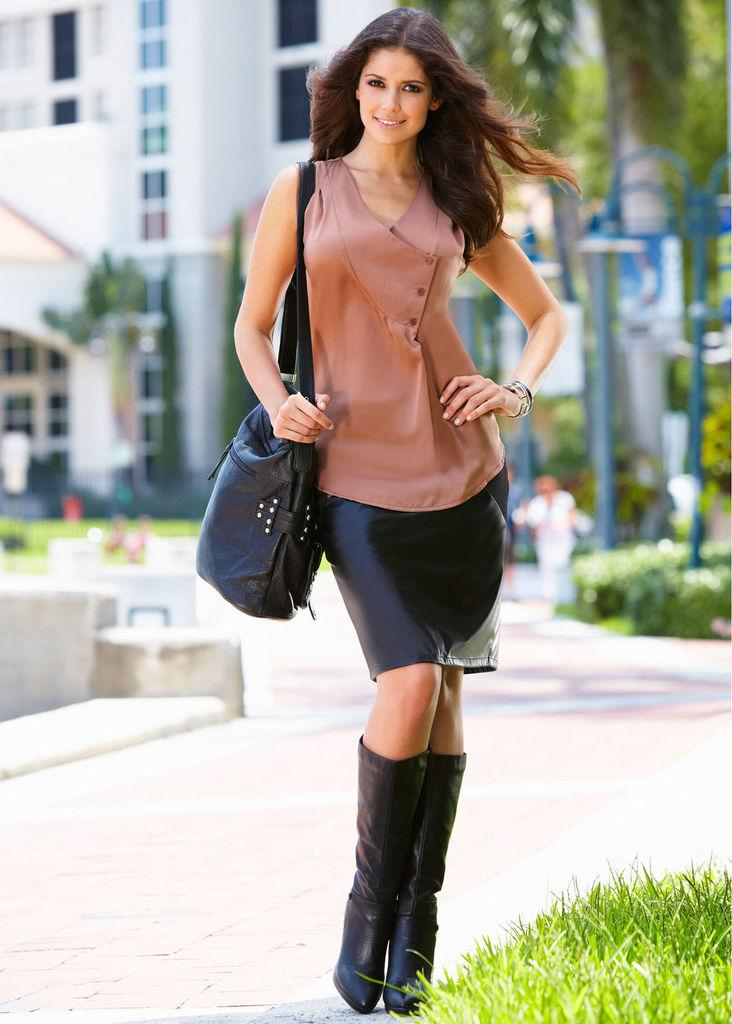What is the main subject in the foreground of the image? There is a woman standing in the foreground of the image. What is the woman wearing on her body? The woman is wearing a black bag. What type of natural environment can be seen in the image? There is grass visible in the bottom right-hand corner of the image. What is the background of the image? The background of the image is the sky. Can you hear the woman coughing in the image? There is no sound present in the image, so it is not possible to determine if the woman is coughing or not. 